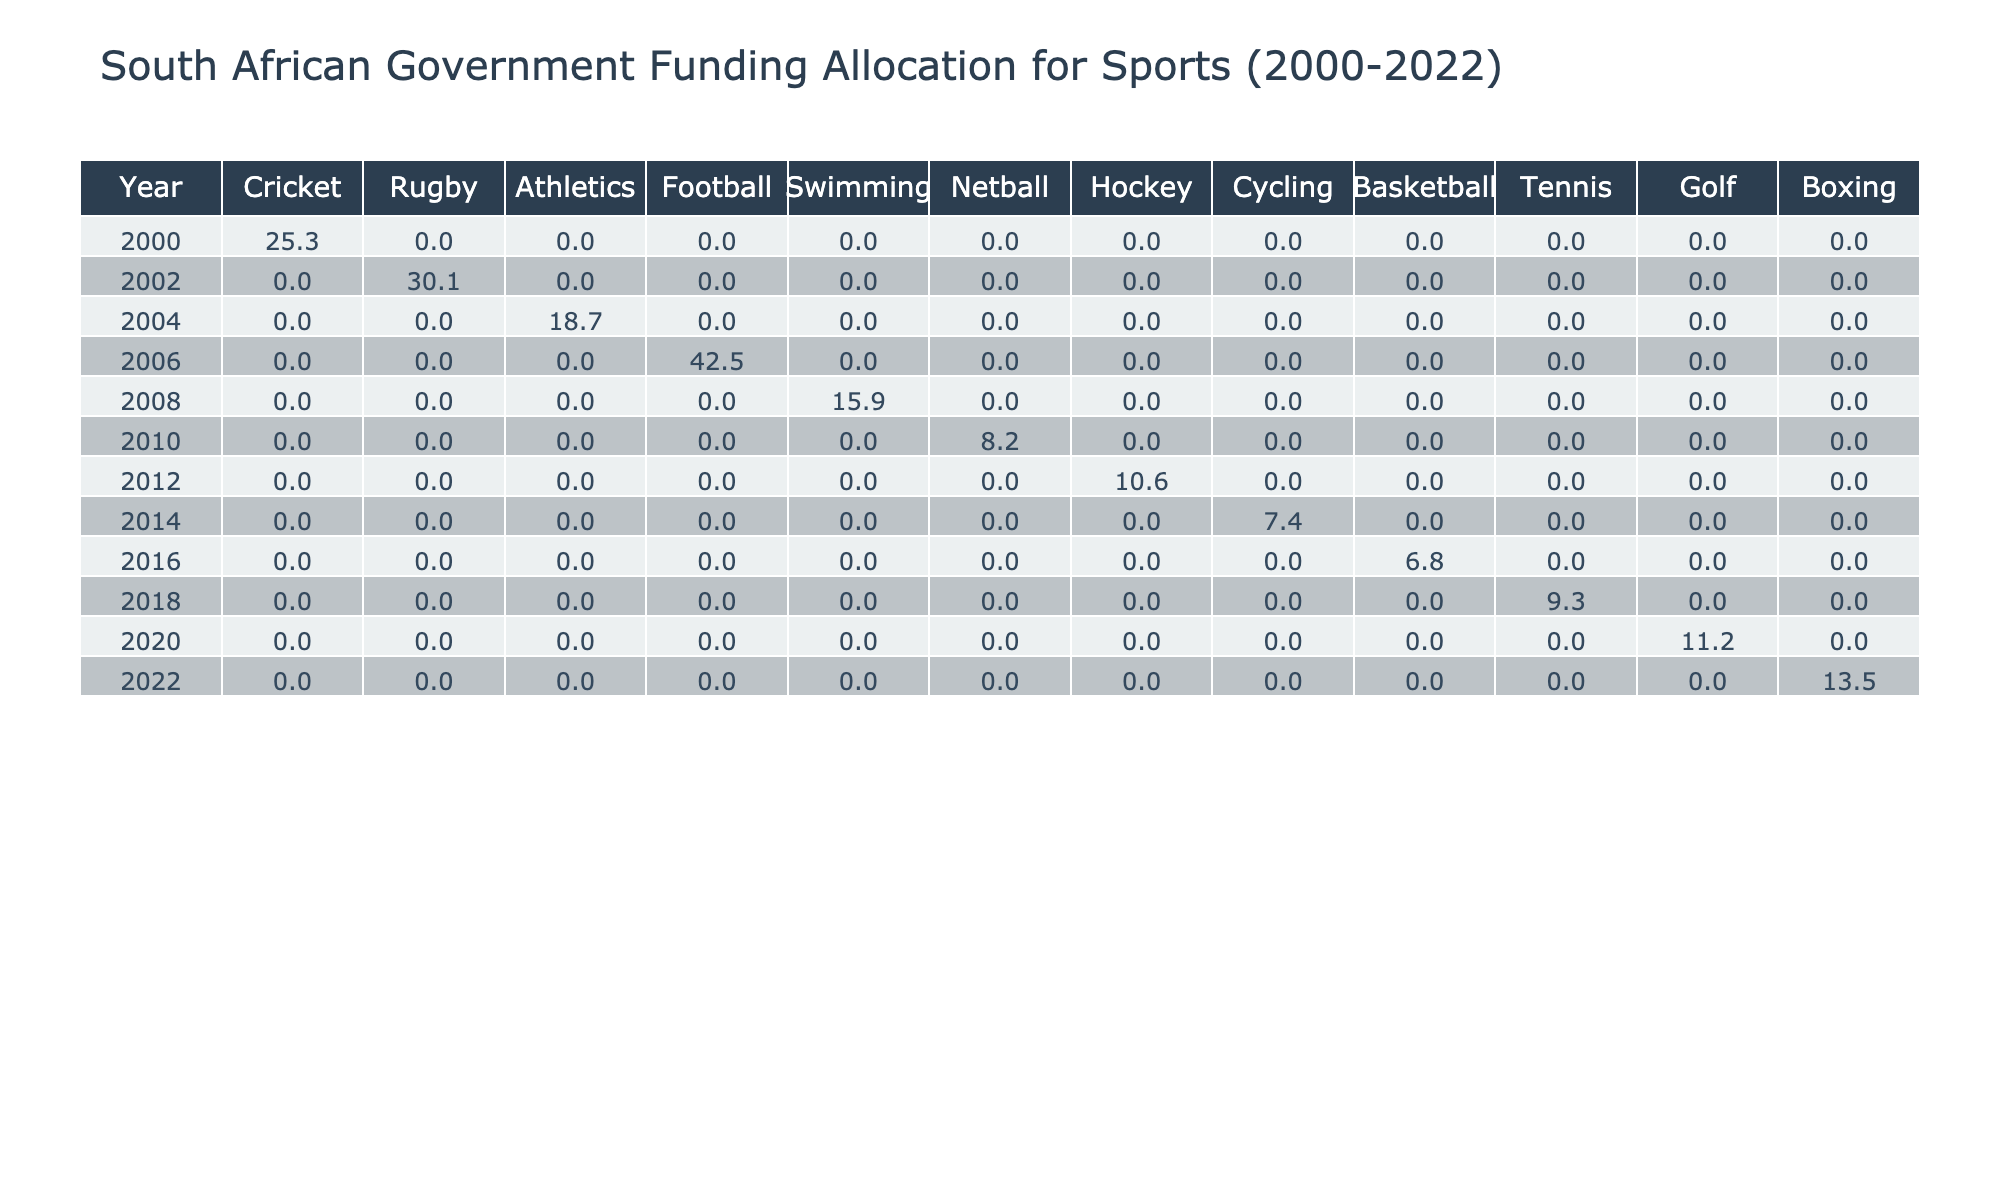What was the funding allocated to Football in 2006? The table shows a specific entry for Football in the year 2006, which is listed directly under the respective columns. The funding allocated is 42.5 million Rand.
Answer: 42.5 million Rand Which sport received the highest funding in a single year? By comparing the funding amounts for all sports across each year in the table, the greatest value is found in the year 2006 for Football, which had a funding allocation of 42.5 million Rand.
Answer: Football in 2006 How much funding was allocated to Athletics in 2004? The table includes an entry for Athletics in the year 2004, where the funding is directly specified as 18.7 million Rand.
Answer: 18.7 million Rand Which two sports had the lowest funding allocation in the years provided? By examining the funding allocations listed in the table, Cycling and Basketball are identified as the two sports with the lowest amounts, which are 7.4 million Rand and 6.8 million Rand, respectively.
Answer: Cycling and Basketball What was the total funding for Rugby and Cricket combined from 2000 to 2022? To find the total funding for Rugby and Cricket, I check each entry for these sports: Rugby received 30.1 million Rand (2002), and Cricket received 25.3 million Rand (2000). The total is calculated as 30.1 + 25.3 = 55.4 million Rand.
Answer: 55.4 million Rand Which sport had an increase in funding from 2000 to 2022, and what was that amount? Analyzing the funding allocations from 2000 to 2022, I note that Boxing, which received 13.5 million Rand in 2022, did not have funding recorded in 2000 (it was not funded), indicating a notable increase of 13.5 million Rand.
Answer: Boxing, increase of 13.5 million Rand What is the average funding allocation for all sports from 2000 to 2022? To find the average, I first sum all the funding allocations (25.3 + 30.1 + 18.7 + 42.5 + 15.9 + 8.2 + 10.6 + 7.4 + 6.8 + 9.3 + 11.2 + 13.5 =  225.2 million Rand) and then divide by the number of sports (12), which gives an average of 225.2 / 12 = 18.77 million Rand.
Answer: 18.77 million Rand Was there any sport that had consistent funding amounts throughout the years listed? A careful review of the table entries reveals that there are no sports with consistent funding amounts across multiple years, each sport's funding varied each year it was allocated.
Answer: No In which years was Swimming funded, and what was the amount in each of those years? Upon checking the table, Swimming is shown to have received funding in 2008 only, with an allocation of 15.9 million Rand for that year.
Answer: 2008, 15.9 million Rand What was the funding trend for Hockey from 2000 to 2022? The table indicates that Hockey was funded in 2012 with an amount of 10.6 million Rand and does not appear in the years before or after, indicating no trend or fluctuation over the years, but a single year's allocation.
Answer: No trend, funded only in 2012 